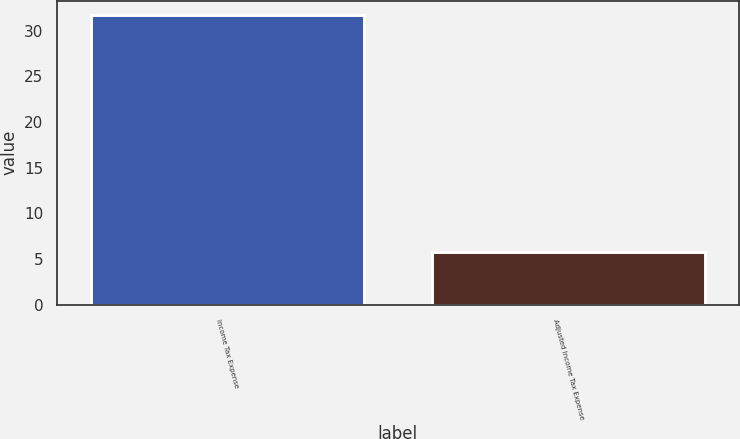<chart> <loc_0><loc_0><loc_500><loc_500><bar_chart><fcel>Income Tax Expense<fcel>Adjusted Income Tax Expense<nl><fcel>31.7<fcel>5.8<nl></chart> 